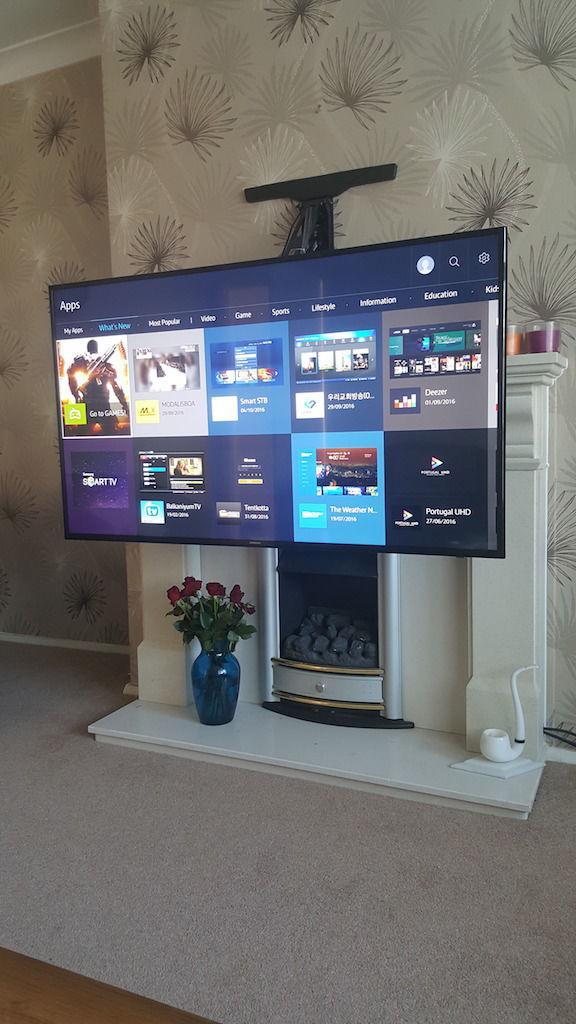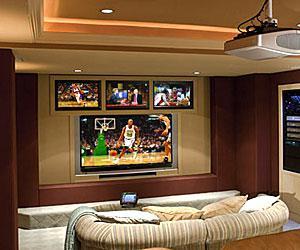The first image is the image on the left, the second image is the image on the right. For the images shown, is this caption "Cushioned furniture is positioned near screens mounted on the wall in one of the images." true? Answer yes or no. Yes. The first image is the image on the left, the second image is the image on the right. Examine the images to the left and right. Is the description "The right image shows a symmetrical grouping of at least four screens mounted on an inset wall surrounded by brown wood." accurate? Answer yes or no. Yes. 